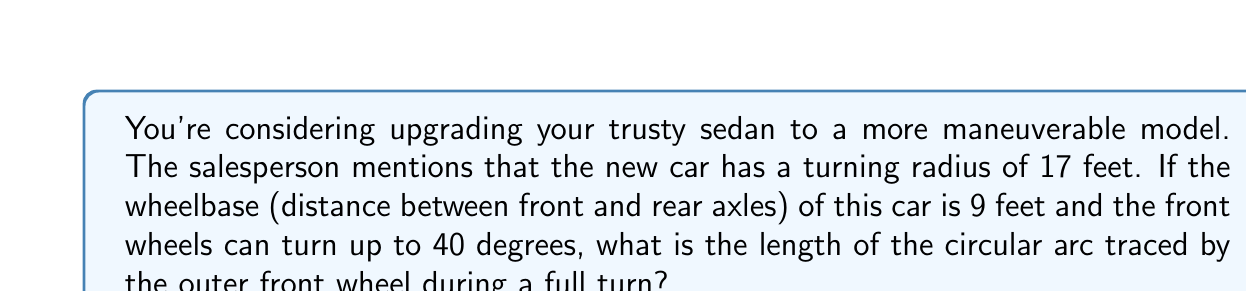Give your solution to this math problem. Let's approach this step-by-step:

1) First, we need to understand that the turning radius is measured to the center of the rear axle. Let's call this radius $R$.

2) The radius to the outer front wheel will be larger. We can find this using the Ackermann steering geometry:

   $$R_{outer} = \sqrt{R^2 + L^2}$$

   Where $L$ is the wheelbase.

3) Plugging in our values:

   $$R_{outer} = \sqrt{17^2 + 9^2} = \sqrt{370} \approx 19.24 \text{ feet}$$

4) Now, we need to find the angle swept by this outer wheel. It's not the same as the wheel turning angle. We can find it using:

   $$\theta = 2 \arcsin(\frac{L}{2R})$$

5) Calculating:

   $$\theta = 2 \arcsin(\frac{9}{2(17)}) \approx 0.5305 \text{ radians} \approx 30.4°$$

6) The length of a circular arc is given by:

   $$s = R_{outer} \cdot \theta$$

   Where $\theta$ is in radians.

7) Therefore, the length of the arc is:

   $$s = 19.24 \cdot 0.5305 \approx 10.21 \text{ feet}$$
Answer: $10.21 \text{ feet}$ 